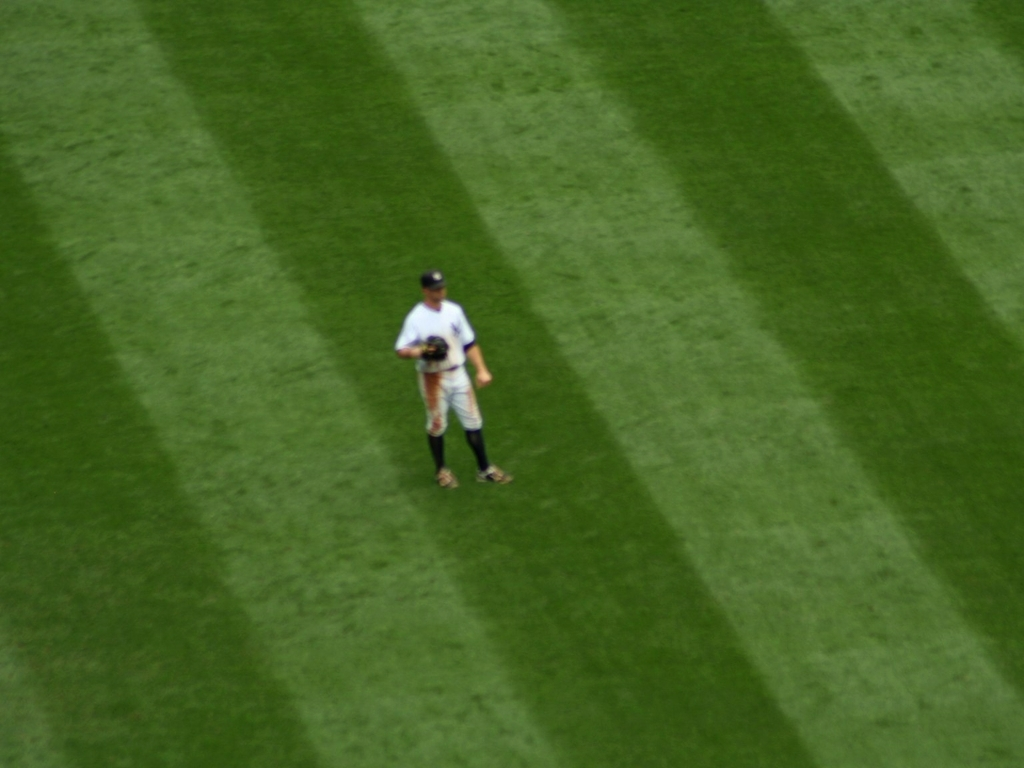Is there any indication of the speed of the person? There's no clear indication of rapid movement since the image is blurry; it's challenging to determine the person's speed. However, if the blur is due to motion rather than focus issues, this may suggest that the person was moving quickly when the photo was taken. 